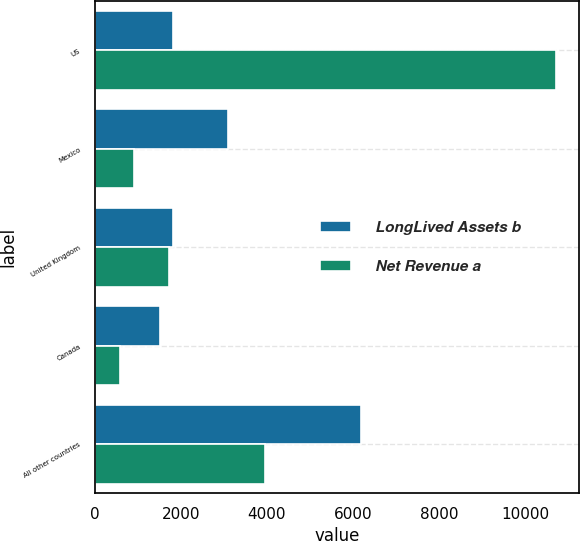Convert chart. <chart><loc_0><loc_0><loc_500><loc_500><stacked_bar_chart><ecel><fcel>US<fcel>Mexico<fcel>United Kingdom<fcel>Canada<fcel>All other countries<nl><fcel>LongLived Assets b<fcel>1821<fcel>3095<fcel>1821<fcel>1509<fcel>6200<nl><fcel>Net Revenue a<fcel>10723<fcel>902<fcel>1715<fcel>582<fcel>3948<nl></chart> 